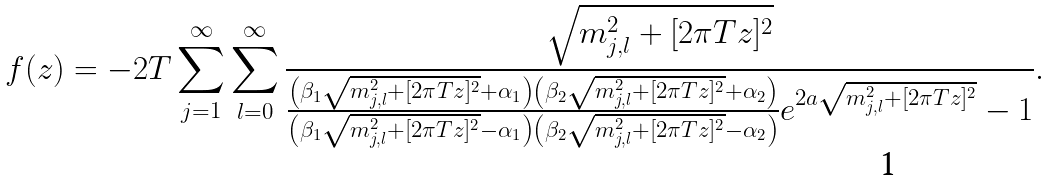Convert formula to latex. <formula><loc_0><loc_0><loc_500><loc_500>f ( z ) = - 2 T \sum _ { j = 1 } ^ { \infty } \sum _ { l = 0 } ^ { \infty } \frac { \sqrt { m _ { j , l } ^ { 2 } + [ 2 \pi T z ] ^ { 2 } } } { \frac { \left ( \beta _ { 1 } \sqrt { m _ { j , l } ^ { 2 } + [ 2 \pi T z ] ^ { 2 } } + \alpha _ { 1 } \right ) \left ( \beta _ { 2 } \sqrt { m _ { j , l } ^ { 2 } + [ 2 \pi T z ] ^ { 2 } } + \alpha _ { 2 } \right ) } { \left ( \beta _ { 1 } \sqrt { m _ { j , l } ^ { 2 } + [ 2 \pi T z ] ^ { 2 } } - \alpha _ { 1 } \right ) \left ( \beta _ { 2 } \sqrt { m _ { j , l } ^ { 2 } + [ 2 \pi T z ] ^ { 2 } } - \alpha _ { 2 } \right ) } e ^ { 2 a \sqrt { m _ { j , l } ^ { 2 } + [ 2 \pi T z ] ^ { 2 } } } - 1 } .</formula> 